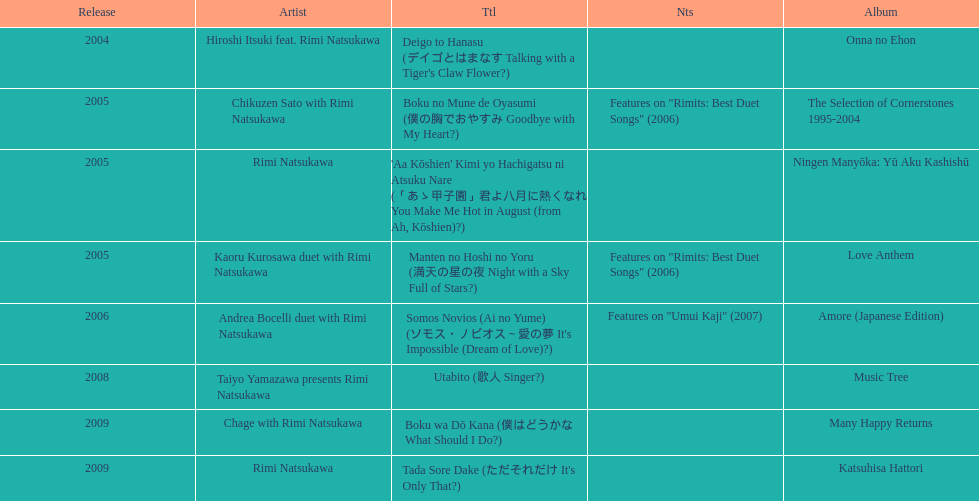Which was not released in 2004, onna no ehon or music tree? Music Tree. 